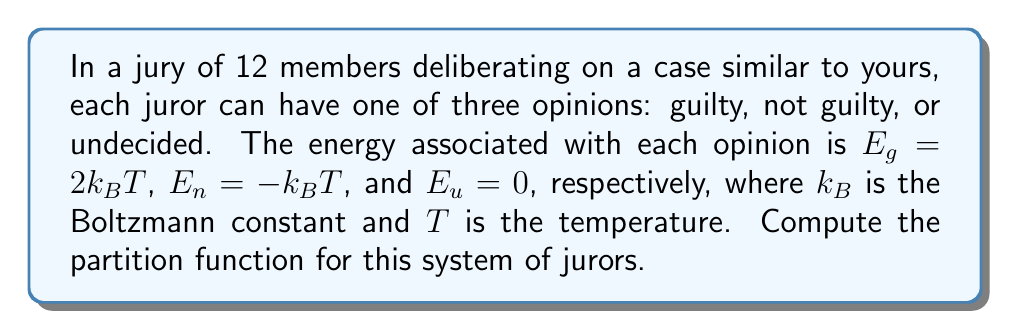What is the answer to this math problem? To solve this problem, we'll follow these steps:

1) The partition function $Z$ for a system is given by:

   $$Z = \sum_i e^{-\beta E_i}$$

   where $\beta = \frac{1}{k_BT}$ and $E_i$ are the possible energy states.

2) In this case, we have three possible states for each juror:
   - Guilty: $E_g = 2k_BT$
   - Not guilty: $E_n = -k_BT$
   - Undecided: $E_u = 0$

3) Let's calculate $e^{-\beta E_i}$ for each state:
   - Guilty: $e^{-\beta E_g} = e^{-\frac{2k_BT}{k_BT}} = e^{-2}$
   - Not guilty: $e^{-\beta E_n} = e^{\frac{k_BT}{k_BT}} = e^1 = e$
   - Undecided: $e^{-\beta E_u} = e^0 = 1$

4) For a single juror, the partition function would be:

   $$Z_1 = e^{-2} + e + 1$$

5) Since there are 12 independent jurors, and each can be in any of these states, the total partition function is the product of the individual partition functions:

   $$Z = (Z_1)^{12} = (e^{-2} + e + 1)^{12}$$

This is the final form of the partition function for the system of 12 jurors.
Answer: $$(e^{-2} + e + 1)^{12}$$ 